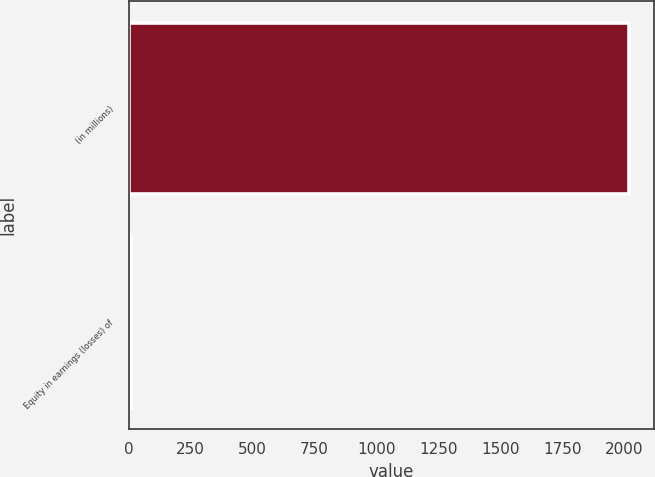Convert chart to OTSL. <chart><loc_0><loc_0><loc_500><loc_500><bar_chart><fcel>(in millions)<fcel>Equity in earnings (losses) of<nl><fcel>2017<fcel>10<nl></chart> 